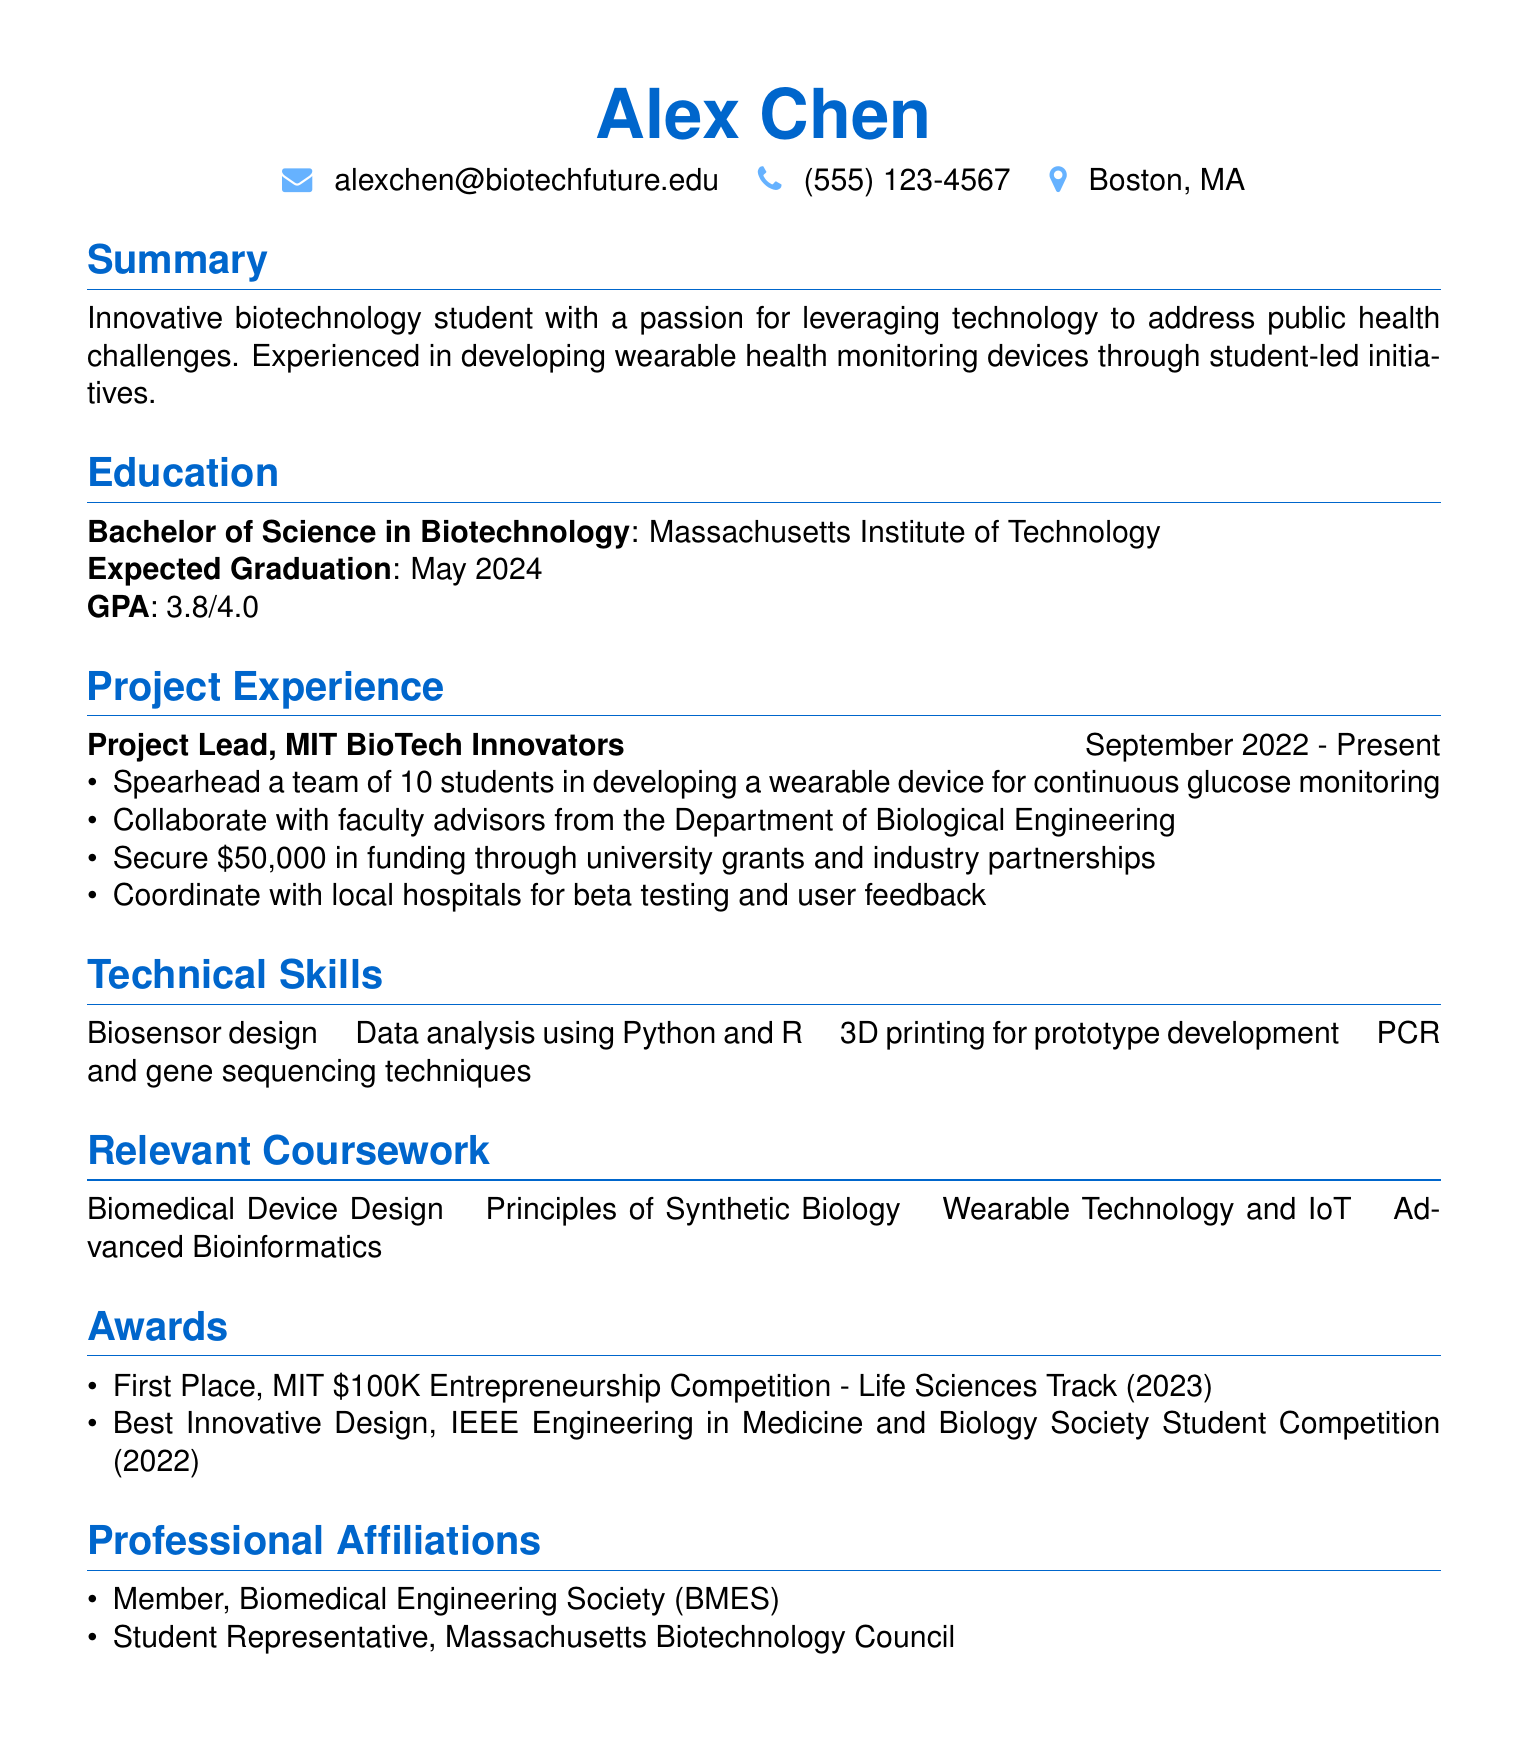What is the name of the applicant? The name of the applicant is stated at the top of the document in the header section.
Answer: Alex Chen What degree is the applicant pursuing? The document clearly mentions the applicant's degree in the education section.
Answer: Bachelor of Science in Biotechnology What is the GPA of the applicant? The GPA is provided in the education section of the document.
Answer: 3.8/4.0 What position does the applicant hold in the project experience? The title of the position is listed under the project experience section.
Answer: Project Lead How much funding did the applicant secure? The amount of funding is mentioned in the project experience responsibilities.
Answer: 50,000 Which universities' student-led initiative is the applicant involved with? The document specifies the name of the institution where the initiative is taking place.
Answer: Massachusetts Institute of Technology What competition did the applicant win first place in? The relevant award details are provided under the awards section.
Answer: MIT 100K Entrepreneurship Competition How many students are on the applicant's project team? The number of students in the team is mentioned in the project experience section.
Answer: 10 What is one technical skill listed in the resume? The technical skills section lists various skills possessed by the applicant.
Answer: Biosensor design 